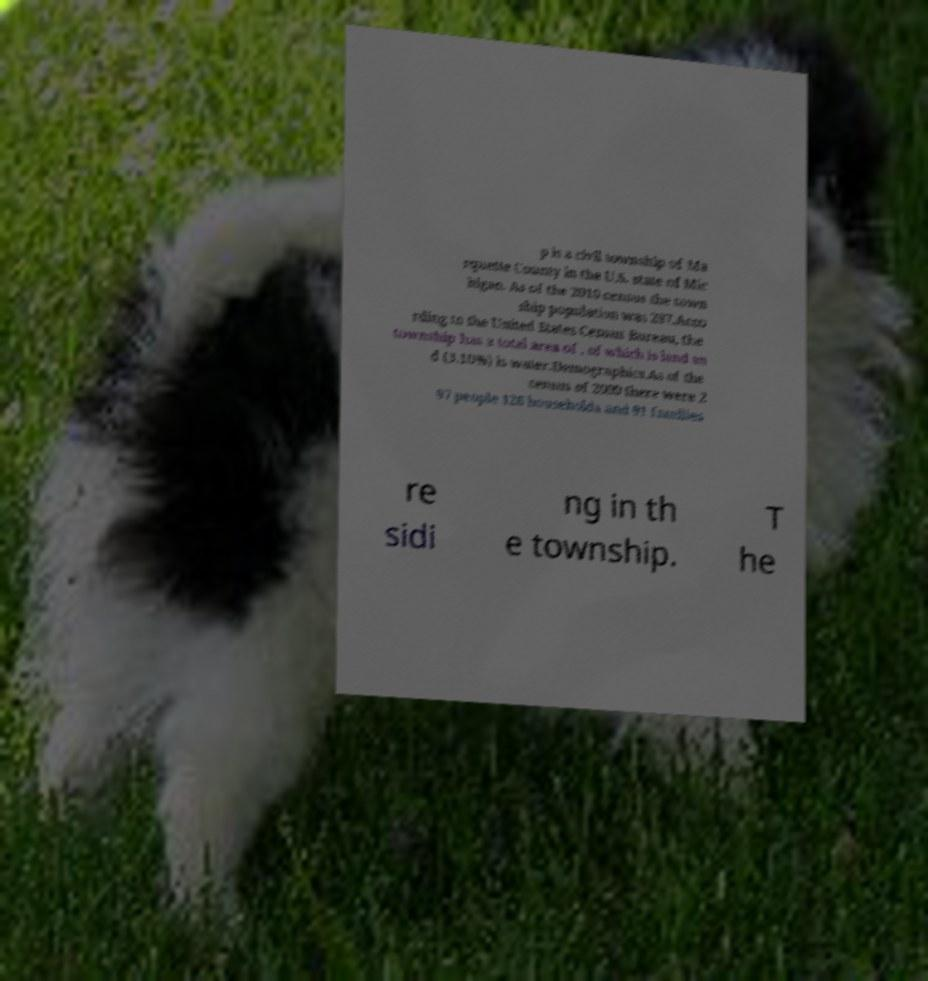I need the written content from this picture converted into text. Can you do that? p is a civil township of Ma rquette County in the U.S. state of Mic higan. As of the 2010 census the town ship population was 297.Acco rding to the United States Census Bureau, the township has a total area of , of which is land an d (3.10%) is water.Demographics.As of the census of 2000 there were 2 97 people 126 households and 91 families re sidi ng in th e township. T he 